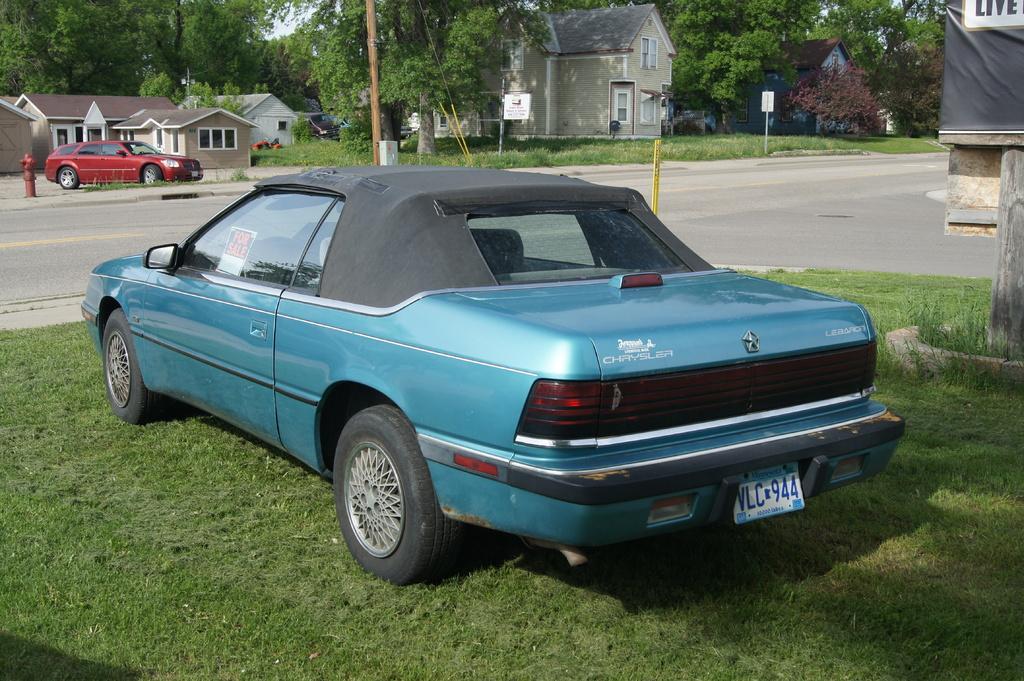Please provide a concise description of this image. In this image I can see few buildings and trees. I can see two cars. I can see the road. There is some grass on the ground. 